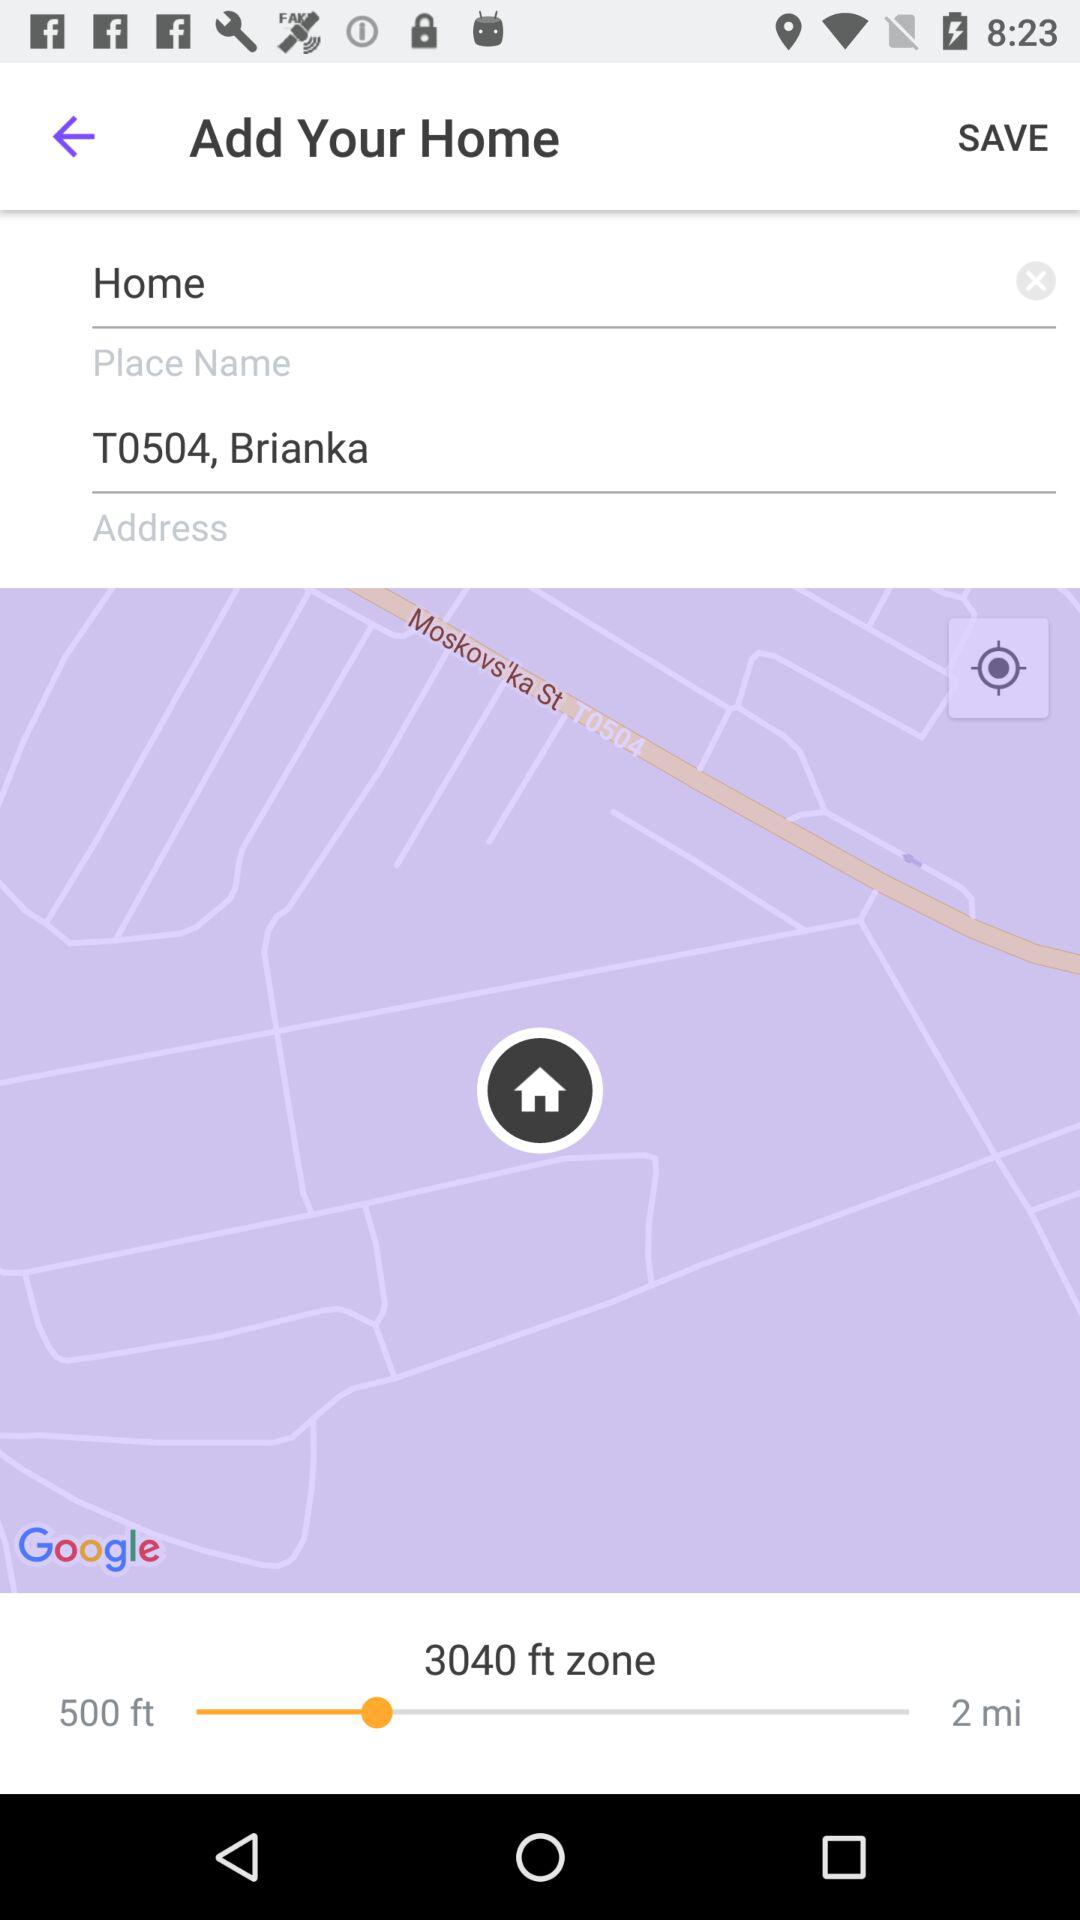How many more feet is the zone than the distance to the home?
Answer the question using a single word or phrase. 2540 